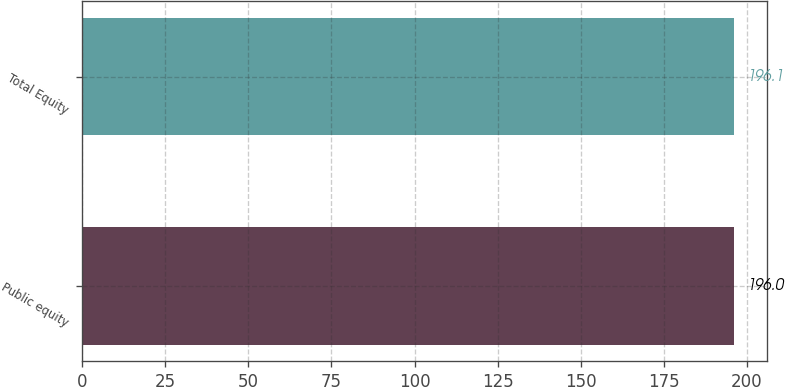Convert chart. <chart><loc_0><loc_0><loc_500><loc_500><bar_chart><fcel>Public equity<fcel>Total Equity<nl><fcel>196<fcel>196.1<nl></chart> 